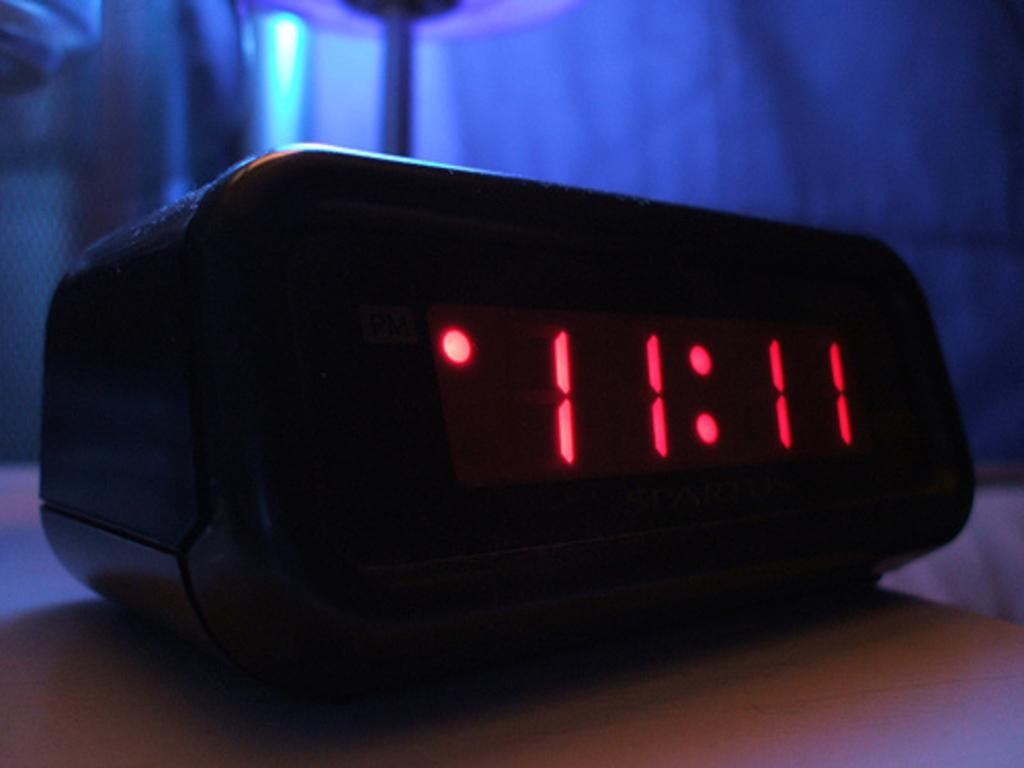<image>
Write a terse but informative summary of the picture. A black digital clock sits on a table and displays the time 11:11 in red digits. 